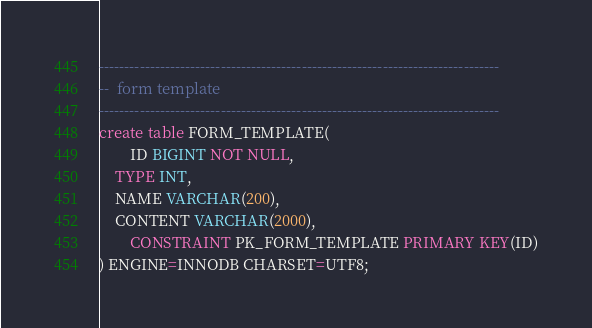<code> <loc_0><loc_0><loc_500><loc_500><_SQL_>

-------------------------------------------------------------------------------
--  form template
-------------------------------------------------------------------------------
create table FORM_TEMPLATE(
        ID BIGINT NOT NULL,
	TYPE INT,
	NAME VARCHAR(200),
	CONTENT VARCHAR(2000),
        CONSTRAINT PK_FORM_TEMPLATE PRIMARY KEY(ID)
) ENGINE=INNODB CHARSET=UTF8;







</code> 